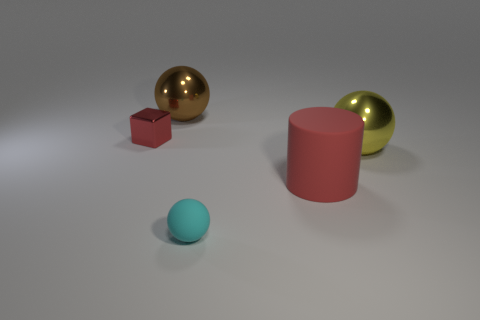Subtract all cylinders. How many objects are left? 4 Subtract 1 spheres. How many spheres are left? 2 Subtract all yellow balls. Subtract all green cylinders. How many balls are left? 2 Subtract all purple cubes. How many blue cylinders are left? 0 Subtract all big rubber cylinders. Subtract all metallic spheres. How many objects are left? 2 Add 4 big brown metallic things. How many big brown metallic things are left? 5 Add 1 brown spheres. How many brown spheres exist? 2 Add 3 tiny rubber spheres. How many objects exist? 8 Subtract all large spheres. How many spheres are left? 1 Subtract 1 red cylinders. How many objects are left? 4 